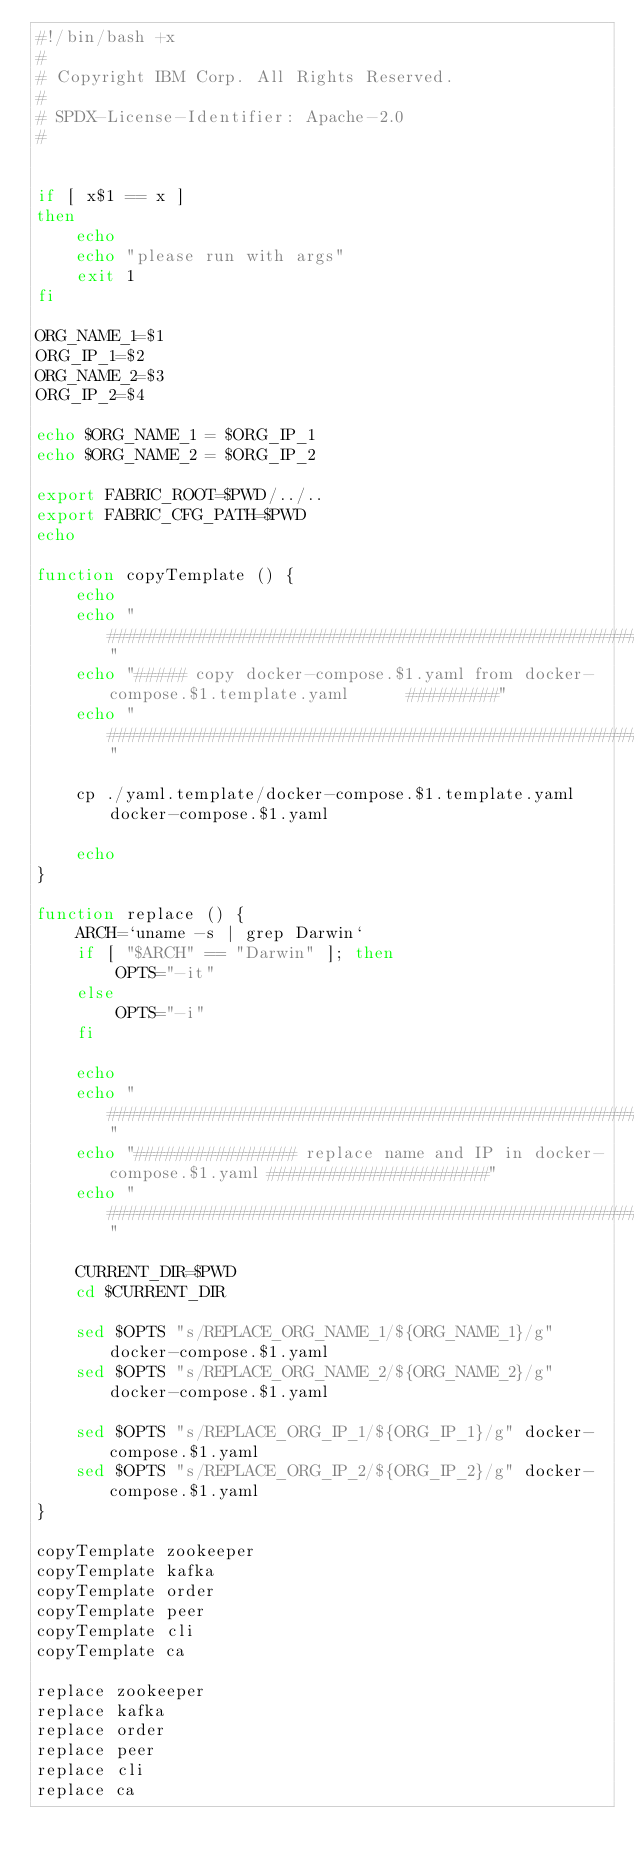<code> <loc_0><loc_0><loc_500><loc_500><_Bash_>#!/bin/bash +x
#
# Copyright IBM Corp. All Rights Reserved.
#
# SPDX-License-Identifier: Apache-2.0
#


if [ x$1 == x ]
then
    echo
	echo "please run with args"
	exit 1
fi

ORG_NAME_1=$1
ORG_IP_1=$2
ORG_NAME_2=$3
ORG_IP_2=$4

echo $ORG_NAME_1 = $ORG_IP_1
echo $ORG_NAME_2 = $ORG_IP_2

export FABRIC_ROOT=$PWD/../..
export FABRIC_CFG_PATH=$PWD
echo

function copyTemplate () {
	echo
	echo "#####################################################################################"
	echo "##### copy docker-compose.$1.yaml from docker-compose.$1.template.yaml      #########"
	echo "#####################################################################################"

	cp ./yaml.template/docker-compose.$1.template.yaml docker-compose.$1.yaml

	echo
}

function replace () {
	ARCH=`uname -s | grep Darwin`
	if [ "$ARCH" == "Darwin" ]; then
		OPTS="-it"
	else
		OPTS="-i"
	fi

	echo
	echo "#####################################################################################"
	echo "################ replace name and IP in docker-compose.$1.yaml ######################"
	echo "#####################################################################################"

	CURRENT_DIR=$PWD
	cd $CURRENT_DIR
	
	sed $OPTS "s/REPLACE_ORG_NAME_1/${ORG_NAME_1}/g" docker-compose.$1.yaml
	sed $OPTS "s/REPLACE_ORG_NAME_2/${ORG_NAME_2}/g" docker-compose.$1.yaml
	
	sed $OPTS "s/REPLACE_ORG_IP_1/${ORG_IP_1}/g" docker-compose.$1.yaml
	sed $OPTS "s/REPLACE_ORG_IP_2/${ORG_IP_2}/g" docker-compose.$1.yaml
}

copyTemplate zookeeper
copyTemplate kafka
copyTemplate order
copyTemplate peer
copyTemplate cli
copyTemplate ca

replace zookeeper
replace kafka
replace order
replace peer
replace cli
replace ca
</code> 